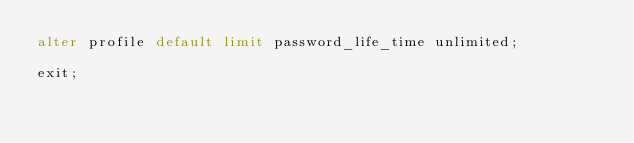<code> <loc_0><loc_0><loc_500><loc_500><_SQL_>alter profile default limit password_life_time unlimited;

exit;

</code> 